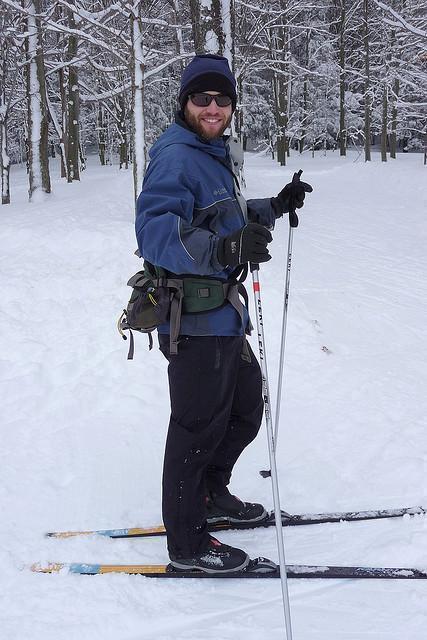What type of skiing is he likely doing?
Select the accurate answer and provide explanation: 'Answer: answer
Rationale: rationale.'
Options: Slalom, downhill, trick, crosscountry. Answer: crosscountry.
Rationale: The skiing is cross country. 